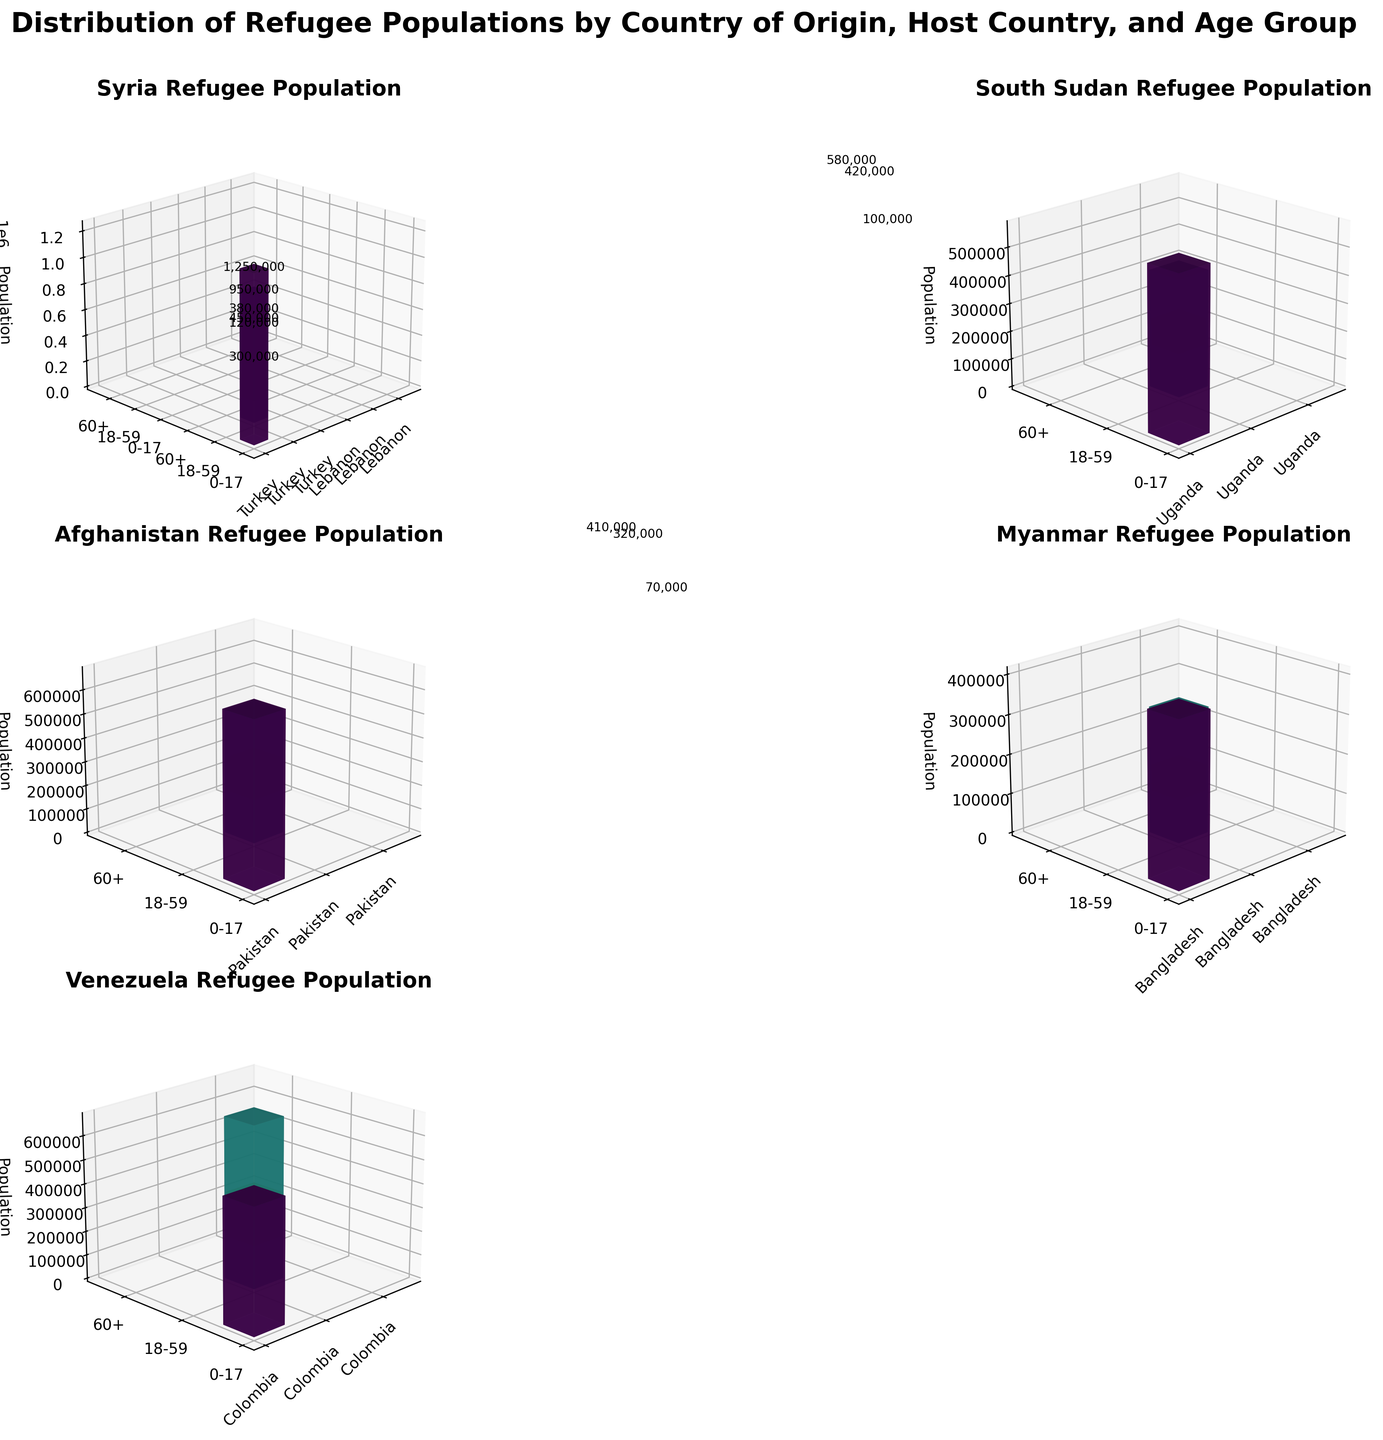What's the title of the figure? The title is usually found above the figure in bold text. For this plot, it indicates the main subject or theme being visualized.
Answer: Distribution of Refugee Populations by Country of Origin, Host Country, and Age Group Which country of origin has refugees hosted in Turkey? Look for subplots where the host country is labeled as Turkey on the x-axis. Identify the corresponding country of origin.
Answer: Syria What's the population of Syrian refugees aged 18-59 in Turkey? Locate the subplot for Syria, find the bar for Turkey on the x-axis and the 18-59 age group on the y-axis, then read off the z-axis value.
Answer: 950,000 How does the population of Venezuelan refugees aged 60+ in Colombia compare to South Sudanese refugees aged 60+ in Uganda? Locate the subplots for Venezuela and South Sudan; then compare the heights of the bars for Colombia (Venezuela) and Uganda (South Sudan) in the 60+ age group.
Answer: 200,000 (Venezuela) vs. 100,000 (South Sudan) What is the total refugee population in Lebanon from Syria? Sum up the populations for all age groups (0-17, 18-59, 60+) in the subplot for Syria where the host country is Lebanon.
Answer: 450,000 + 380,000 + 120,000 = 950,000 Which host country has the highest population of refugees from Afghanistan? Look at the subplot for Afghanistan, compare the heights of the bars for different host countries on the x-axis, and identify the highest one.
Answer: Pakistan What percentage of the total South Sudanese refugee population in Uganda are aged 0-17? Calculate the percentage of 580,000 (0-17) out of the total population (580,000 + 420,000 + 100,000) in the subplot for South Sudan.
Answer: (580,000 / (580,000 + 420,000 + 100,000)) * 100 ≈ 52.73% Which age group has the smallest refugee population from Myanmar in Bangladesh? In the subplot for Myanmar, find the bar that represents Bangladesh on the x-axis and identify the age group with the smallest height/value on the z-axis.
Answer: 60+ How many more refugees aged 18-59 are in Turkey from Syria compared to Lebanon from Syria? Subtract the population of Syrian refugees aged 18-59 in Lebanon from those in Turkey identified in the subplot for Syria.
Answer: 950,000 - 380,000 = 570,000 